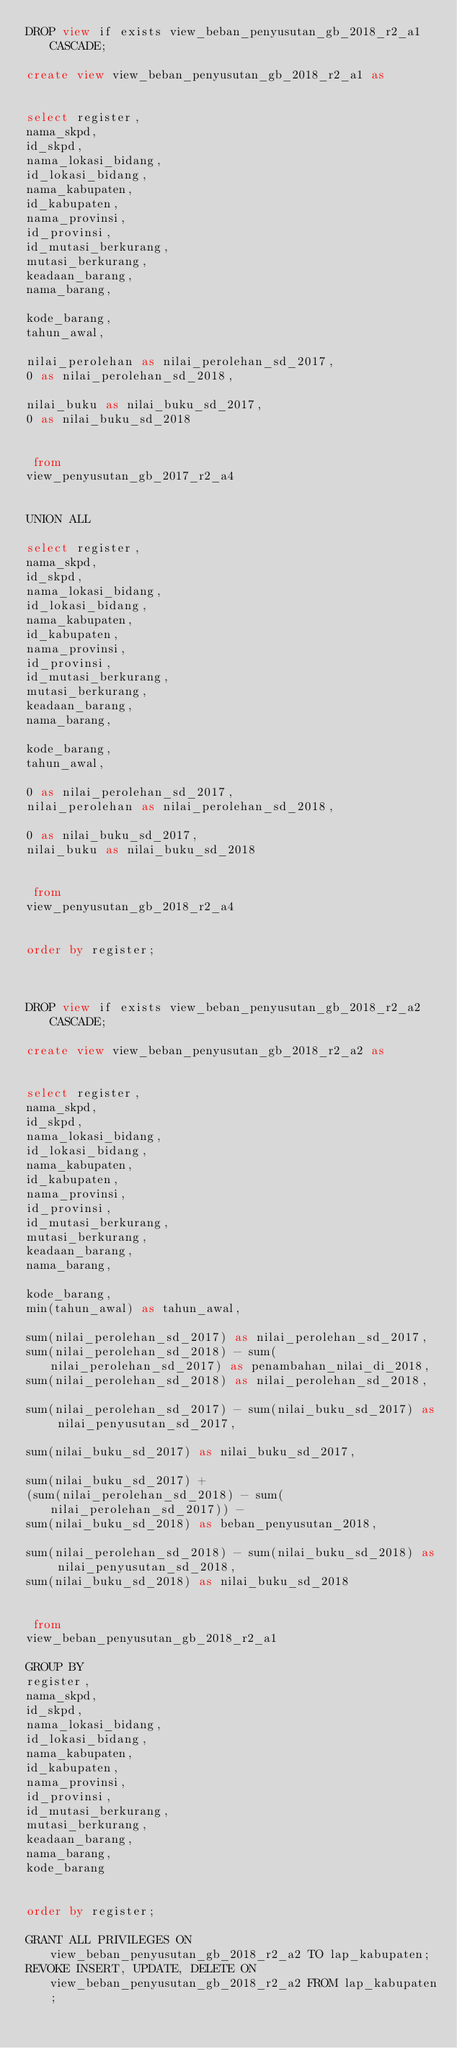Convert code to text. <code><loc_0><loc_0><loc_500><loc_500><_SQL_>DROP view if exists view_beban_penyusutan_gb_2018_r2_a1 CASCADE;

create view view_beban_penyusutan_gb_2018_r2_a1 as


select register,
nama_skpd,
id_skpd,
nama_lokasi_bidang,
id_lokasi_bidang,
nama_kabupaten,
id_kabupaten,
nama_provinsi,
id_provinsi,
id_mutasi_berkurang,
mutasi_berkurang,
keadaan_barang,
nama_barang,

kode_barang,
tahun_awal,

nilai_perolehan as nilai_perolehan_sd_2017,
0 as nilai_perolehan_sd_2018,

nilai_buku as nilai_buku_sd_2017,
0 as nilai_buku_sd_2018


 from
view_penyusutan_gb_2017_r2_a4


UNION ALL

select register,
nama_skpd,
id_skpd,
nama_lokasi_bidang,
id_lokasi_bidang,
nama_kabupaten,
id_kabupaten,
nama_provinsi,
id_provinsi,
id_mutasi_berkurang,
mutasi_berkurang,
keadaan_barang,
nama_barang,

kode_barang,
tahun_awal,

0 as nilai_perolehan_sd_2017,
nilai_perolehan as nilai_perolehan_sd_2018,

0 as nilai_buku_sd_2017,
nilai_buku as nilai_buku_sd_2018


 from
view_penyusutan_gb_2018_r2_a4


order by register;



DROP view if exists view_beban_penyusutan_gb_2018_r2_a2 CASCADE;

create view view_beban_penyusutan_gb_2018_r2_a2 as


select register,
nama_skpd,
id_skpd,
nama_lokasi_bidang,
id_lokasi_bidang,
nama_kabupaten,
id_kabupaten,
nama_provinsi,
id_provinsi,
id_mutasi_berkurang,
mutasi_berkurang,
keadaan_barang,
nama_barang,

kode_barang,
min(tahun_awal) as tahun_awal,

sum(nilai_perolehan_sd_2017) as nilai_perolehan_sd_2017,
sum(nilai_perolehan_sd_2018) - sum(nilai_perolehan_sd_2017) as penambahan_nilai_di_2018,
sum(nilai_perolehan_sd_2018) as nilai_perolehan_sd_2018,

sum(nilai_perolehan_sd_2017) - sum(nilai_buku_sd_2017) as nilai_penyusutan_sd_2017,

sum(nilai_buku_sd_2017) as nilai_buku_sd_2017,

sum(nilai_buku_sd_2017) +
(sum(nilai_perolehan_sd_2018) - sum(nilai_perolehan_sd_2017)) -
sum(nilai_buku_sd_2018) as beban_penyusutan_2018,

sum(nilai_perolehan_sd_2018) - sum(nilai_buku_sd_2018) as nilai_penyusutan_sd_2018,
sum(nilai_buku_sd_2018) as nilai_buku_sd_2018


 from
view_beban_penyusutan_gb_2018_r2_a1

GROUP BY
register,
nama_skpd,
id_skpd,
nama_lokasi_bidang,
id_lokasi_bidang,
nama_kabupaten,
id_kabupaten,
nama_provinsi,
id_provinsi,
id_mutasi_berkurang,
mutasi_berkurang,
keadaan_barang,
nama_barang,
kode_barang


order by register;

GRANT ALL PRIVILEGES ON view_beban_penyusutan_gb_2018_r2_a2 TO lap_kabupaten;
REVOKE INSERT, UPDATE, DELETE ON view_beban_penyusutan_gb_2018_r2_a2 FROM lap_kabupaten;
</code> 